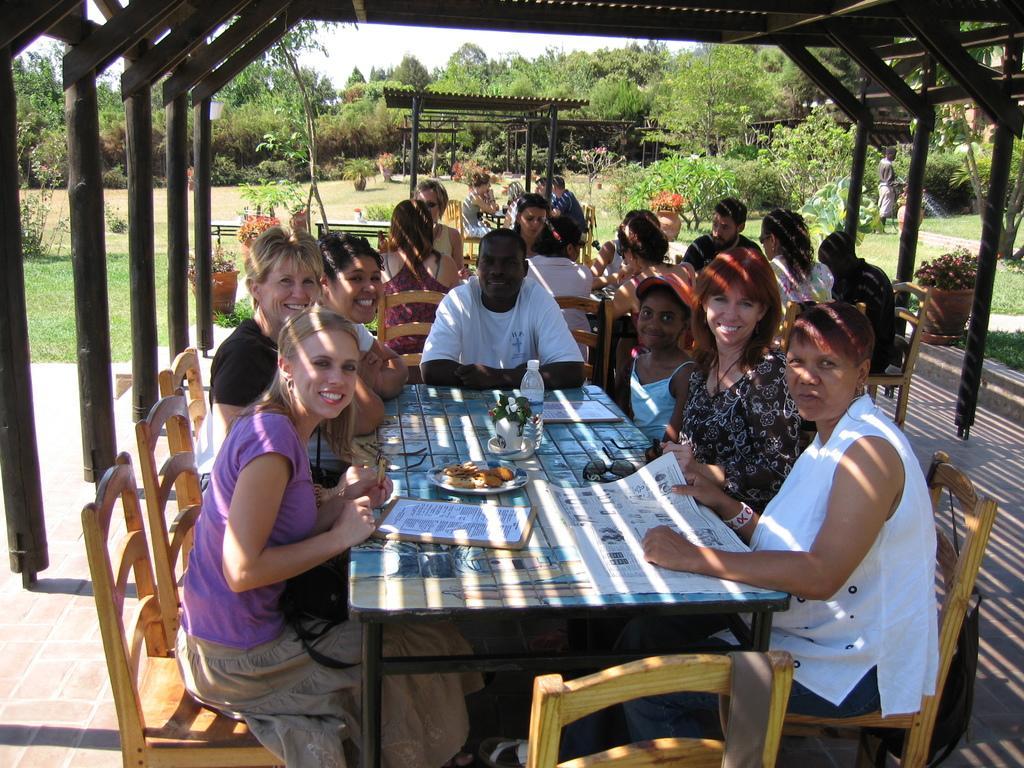Could you give a brief overview of what you see in this image? This is a picture taken in the outdoor, there are a group of people sitting on a chair in front of this people there is a table on the table there is a paper, plate, bottle and flower pot and also there is a goggle. Background of this people there is a shed and trees. On top of this people there is a shed. 